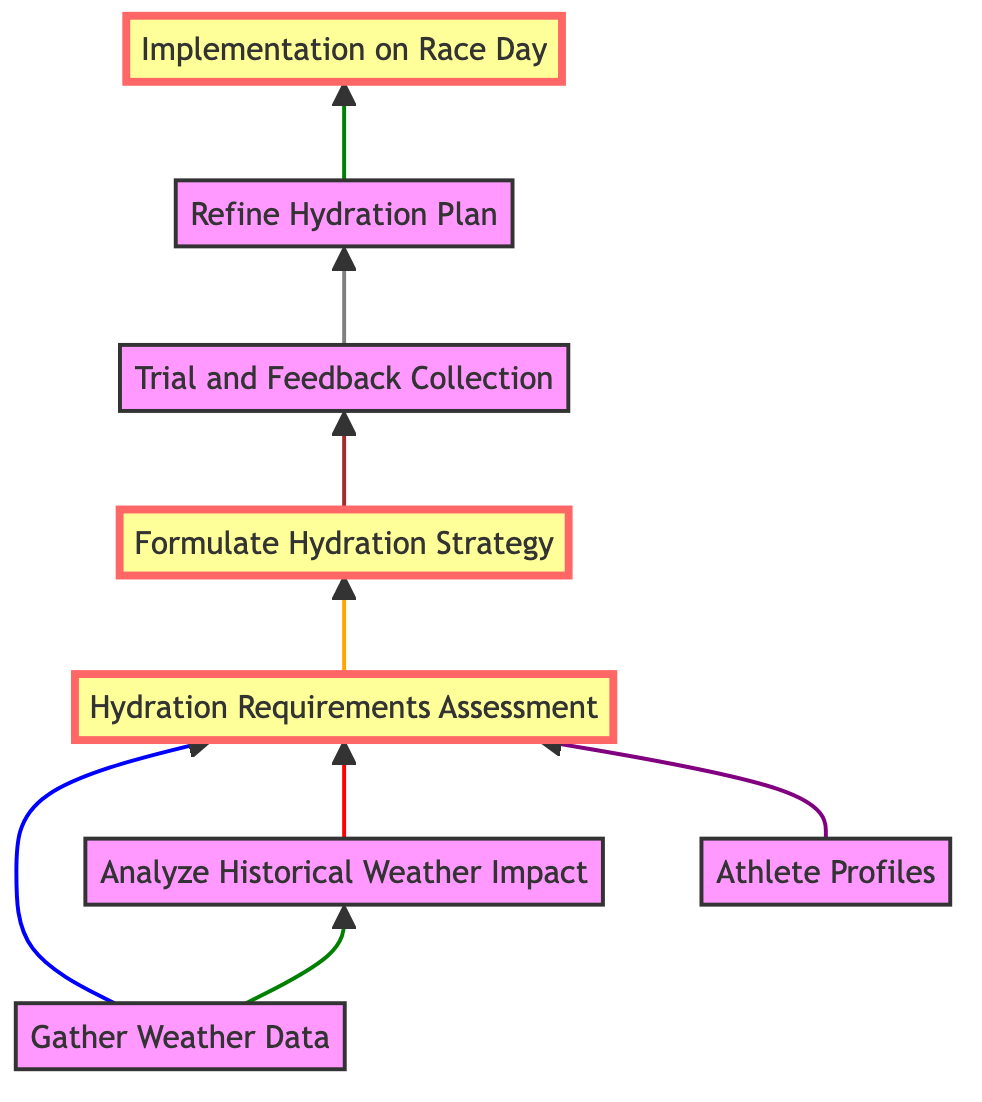What is the first stage in the hydration planning process? The diagram shows that the first stage is "Gather Weather Data," which is indicated as the bottom-most node.
Answer: Gather Weather Data How many nodes are there in total? By counting the nodes in the diagram, we find there are eight distinct stages, or nodes, representing different stages of the hydration plan.
Answer: 8 Which two nodes lead to the "Hydration Requirements Assessment"? The diagram indicates that both "Analyze Historical Weather Impact" and "Athlete Profiles" feed into the "Hydration Requirements Assessment."
Answer: Analyze Historical Weather Impact, Athlete Profiles What is the last stage of the hydration plan process? The final stage, as represented by the top-most node in the diagram, is "Implementation on Race Day."
Answer: Implementation on Race Day How many stages are required before the "Refine Hydration Plan"? According to the diagram, three stages—"Trial and Feedback Collection," "Hydration Requirements Assessment," and "Formulate Hydration Strategy"—must be completed before reaching "Refine Hydration Plan."
Answer: 3 What color is used for the nodes representing the formulation and implementation stages? The diagram indicates that the nodes for "Formulate Hydration Strategy" and "Implementation on Race Day" are highlighted in brown, distinguishing them from other stages.
Answer: Brown What relationship exists between "Formulate Hydration Strategy" and "Trial and Feedback Collection"? The diagram shows a direct progression from "Formulate Hydration Strategy" to "Trial and Feedback Collection," indicating that the latter is a direct consequence of the former.
Answer: Direct progression What must be completed before "Execution on Race Day"? According to the diagram, the stage "Refine Hydration Plan" must be completed prior to "Implementation on Race Day," demonstrating a necessary sequence in the workflow.
Answer: Refine Hydration Plan 